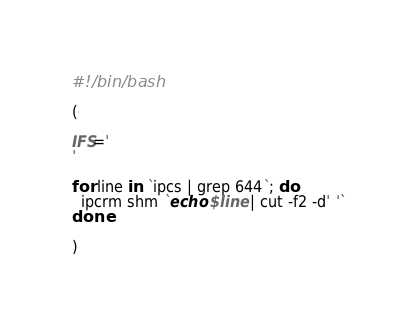Convert code to text. <code><loc_0><loc_0><loc_500><loc_500><_Bash_>#!/bin/bash

(

IFS='
'

for line in `ipcs | grep 644`; do
  ipcrm shm `echo $line | cut -f2 -d' '`
done

)
</code> 